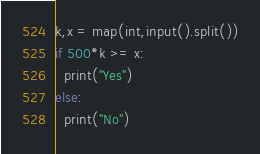Convert code to text. <code><loc_0><loc_0><loc_500><loc_500><_Python_>k,x = map(int,input().split())
if 500*k >= x:
  print("Yes")
else:
  print("No")</code> 